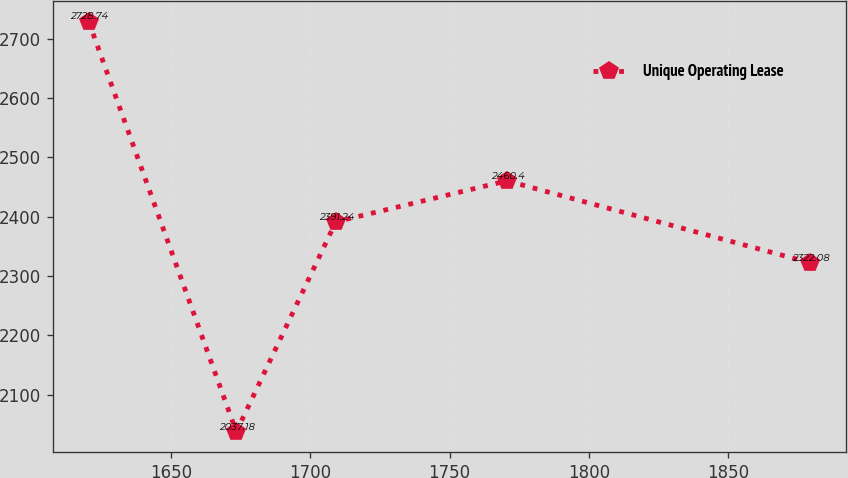<chart> <loc_0><loc_0><loc_500><loc_500><line_chart><ecel><fcel>Unique Operating Lease<nl><fcel>1620.33<fcel>2728.74<nl><fcel>1673.35<fcel>2037.18<nl><fcel>1709.1<fcel>2391.24<nl><fcel>1770.54<fcel>2460.4<nl><fcel>1879.62<fcel>2322.08<nl></chart> 